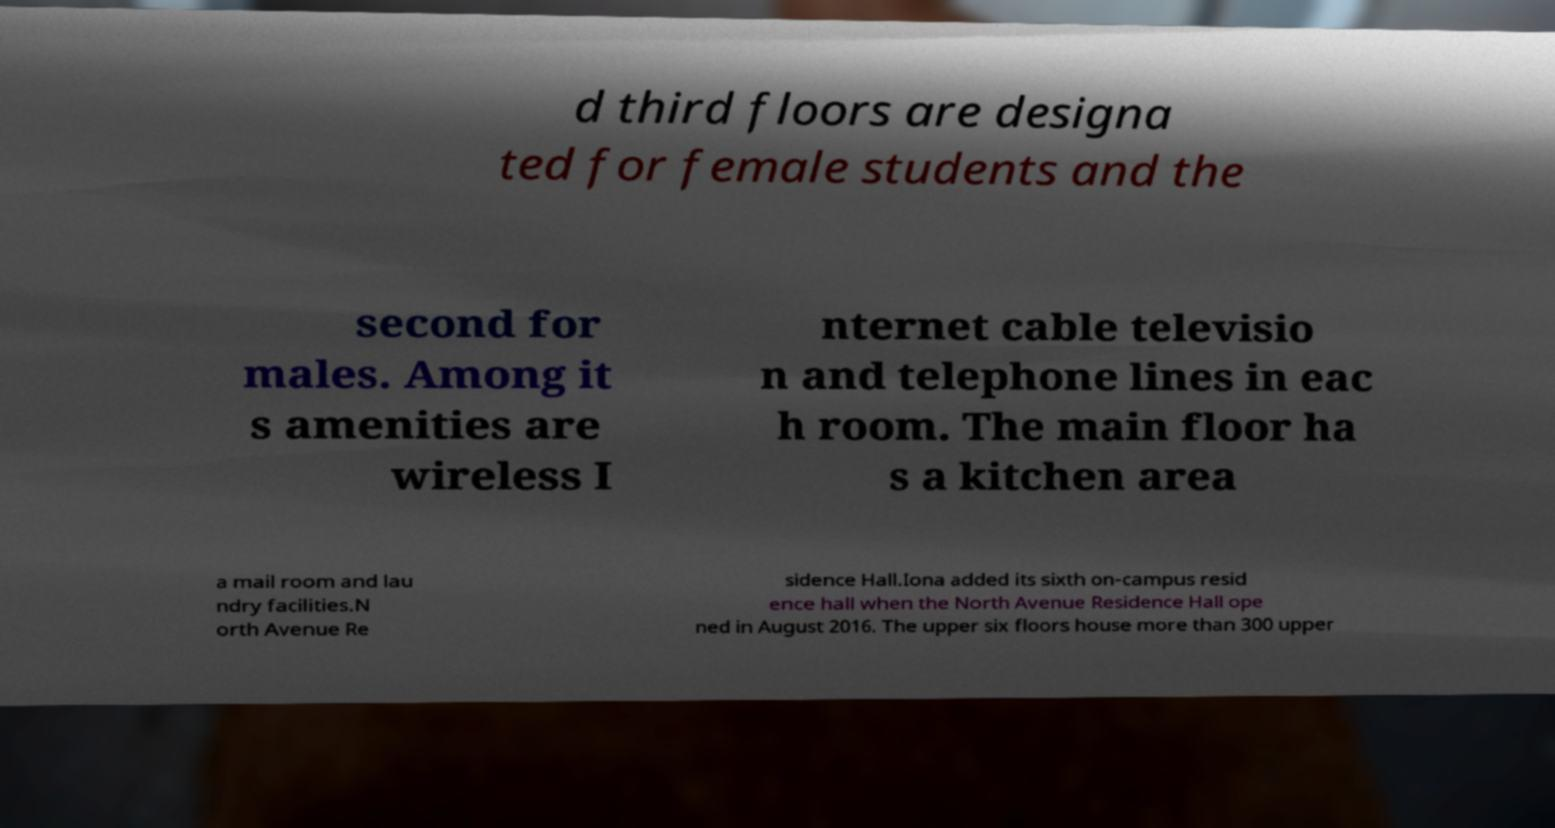What messages or text are displayed in this image? I need them in a readable, typed format. d third floors are designa ted for female students and the second for males. Among it s amenities are wireless I nternet cable televisio n and telephone lines in eac h room. The main floor ha s a kitchen area a mail room and lau ndry facilities.N orth Avenue Re sidence Hall.Iona added its sixth on-campus resid ence hall when the North Avenue Residence Hall ope ned in August 2016. The upper six floors house more than 300 upper 